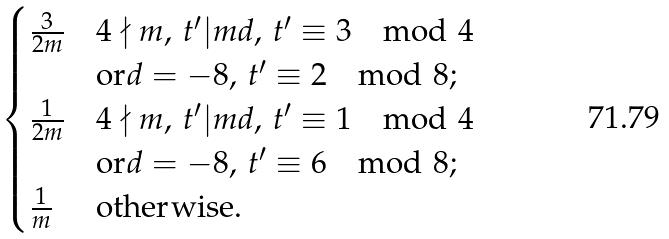<formula> <loc_0><loc_0><loc_500><loc_500>\begin{cases} \frac { 3 } { 2 m } & 4 \nmid m , \, t ^ { \prime } | m d , \, t ^ { \prime } \equiv 3 \mod { 4 } \\ & \text {or} d = - 8 , \, t ^ { \prime } \equiv 2 \mod { 8 } ; \\ \frac { 1 } { 2 m } & 4 \nmid m , \, t ^ { \prime } | m d , \, t ^ { \prime } \equiv 1 \mod { 4 } \\ & \text {or} d = - 8 , \, t ^ { \prime } \equiv 6 \mod { 8 } ; \\ \frac { 1 } { m } & \text {otherwise.} \end{cases}</formula> 